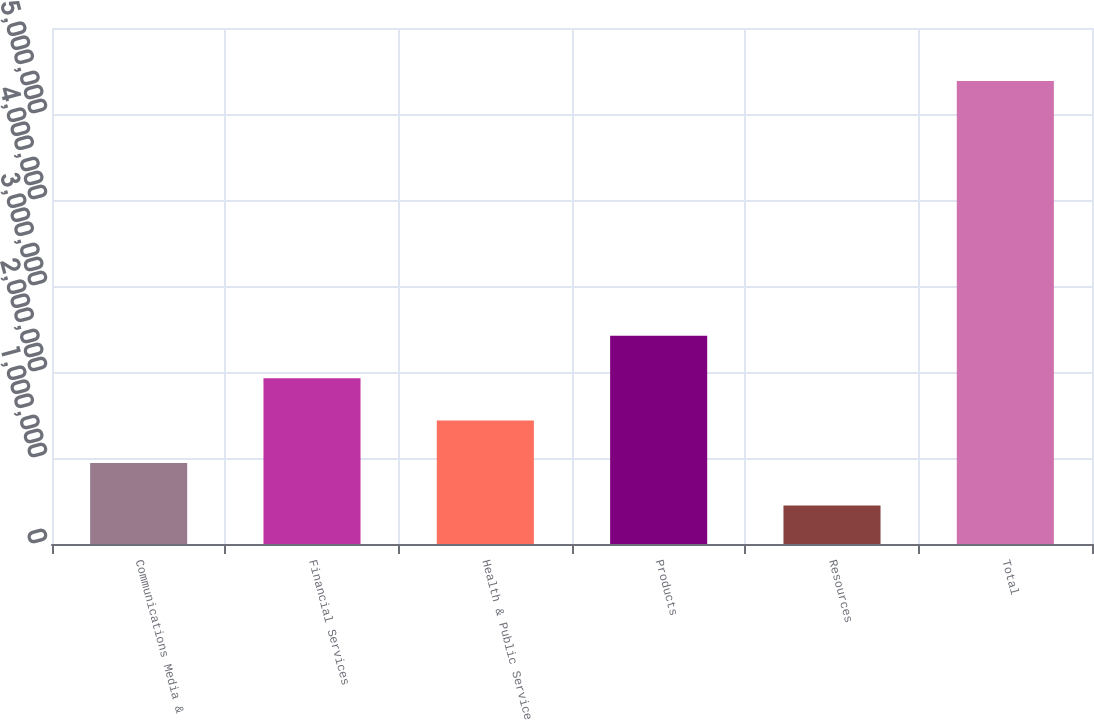Convert chart. <chart><loc_0><loc_0><loc_500><loc_500><bar_chart><fcel>Communications Media &<fcel>Financial Services<fcel>Health & Public Service<fcel>Products<fcel>Resources<fcel>Total<nl><fcel>941490<fcel>1.9285e+06<fcel>1.43499e+06<fcel>2.422e+06<fcel>447988<fcel>5.38301e+06<nl></chart> 